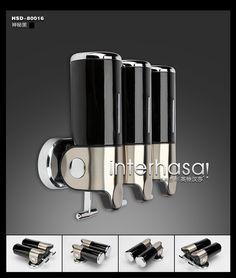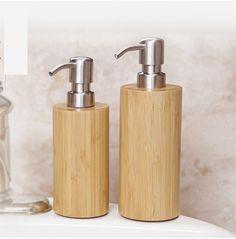The first image is the image on the left, the second image is the image on the right. Assess this claim about the two images: "The image to the right features three soap dispensers.". Correct or not? Answer yes or no. No. The first image is the image on the left, the second image is the image on the right. Evaluate the accuracy of this statement regarding the images: "Both images contain three liquid bathroom product dispensers.". Is it true? Answer yes or no. No. 